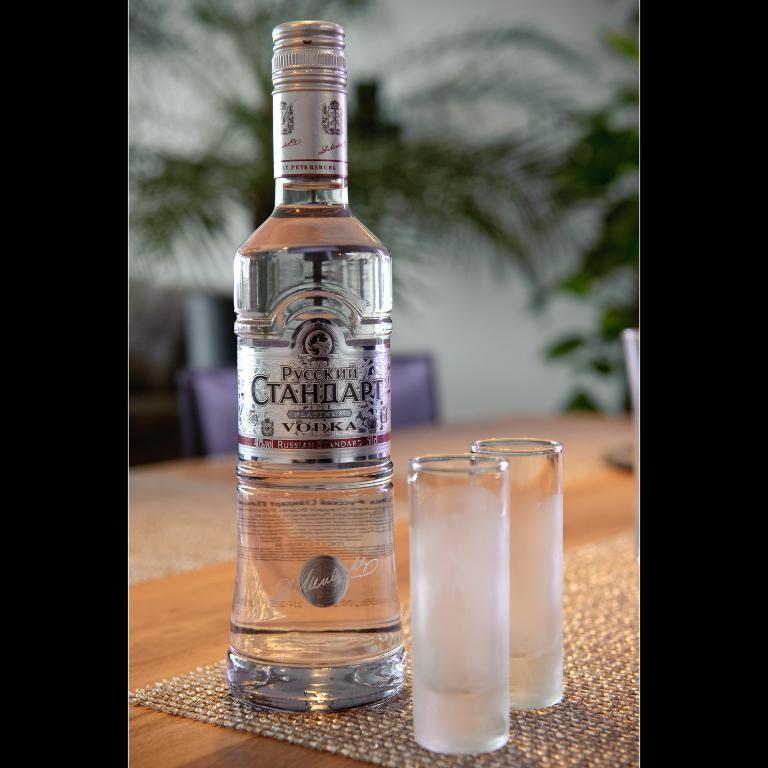Provide a one-sentence caption for the provided image. Two very narrow glasses sit next to a bottle of Pyccknn Vodka. 